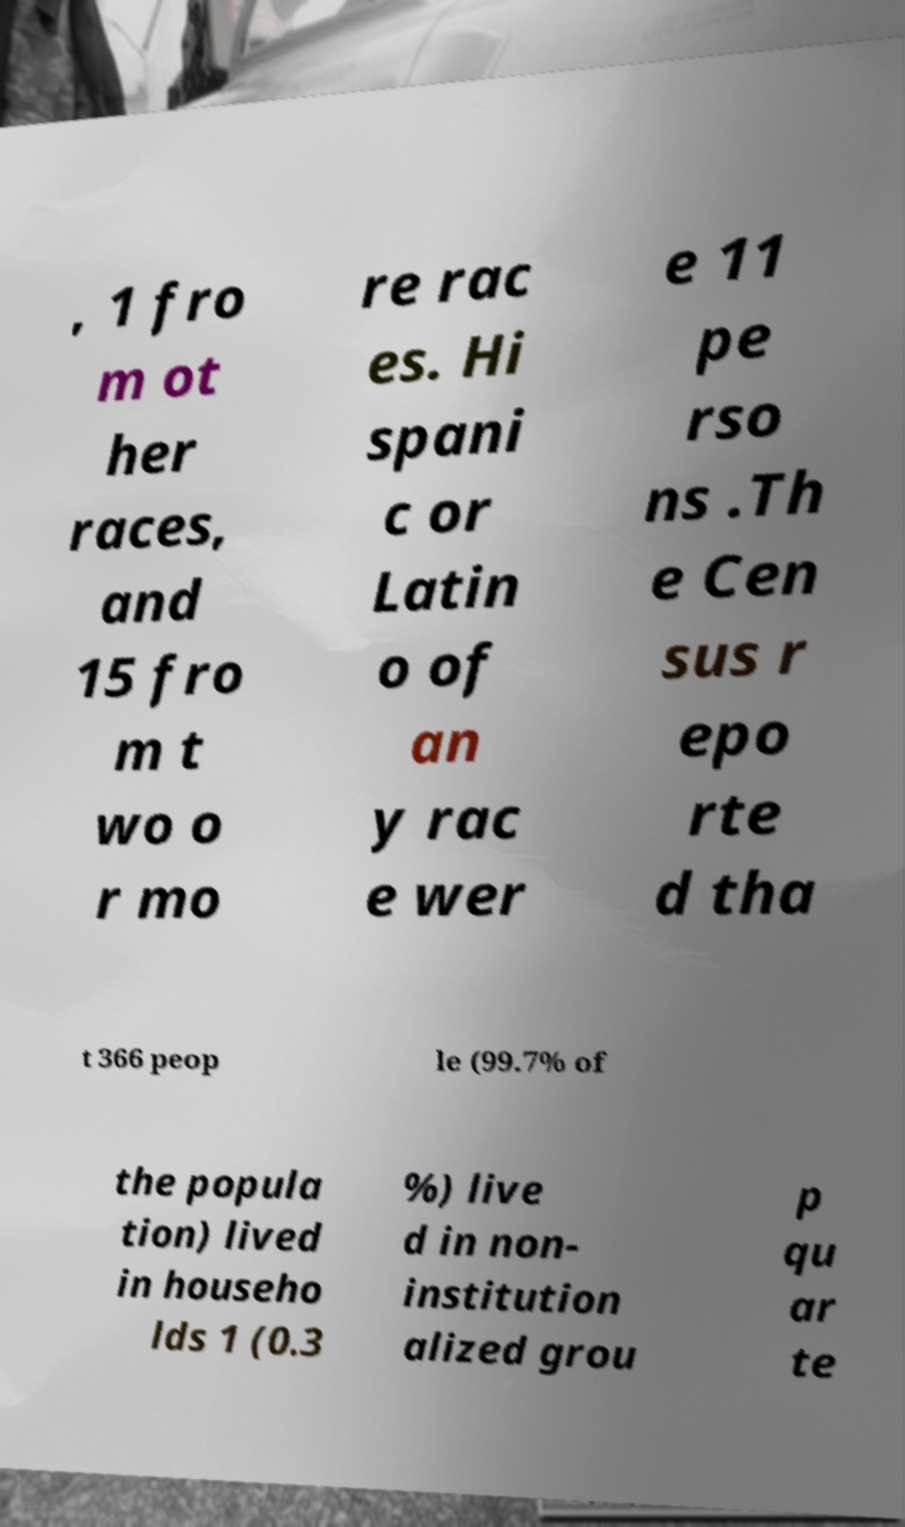Could you assist in decoding the text presented in this image and type it out clearly? , 1 fro m ot her races, and 15 fro m t wo o r mo re rac es. Hi spani c or Latin o of an y rac e wer e 11 pe rso ns .Th e Cen sus r epo rte d tha t 366 peop le (99.7% of the popula tion) lived in househo lds 1 (0.3 %) live d in non- institution alized grou p qu ar te 